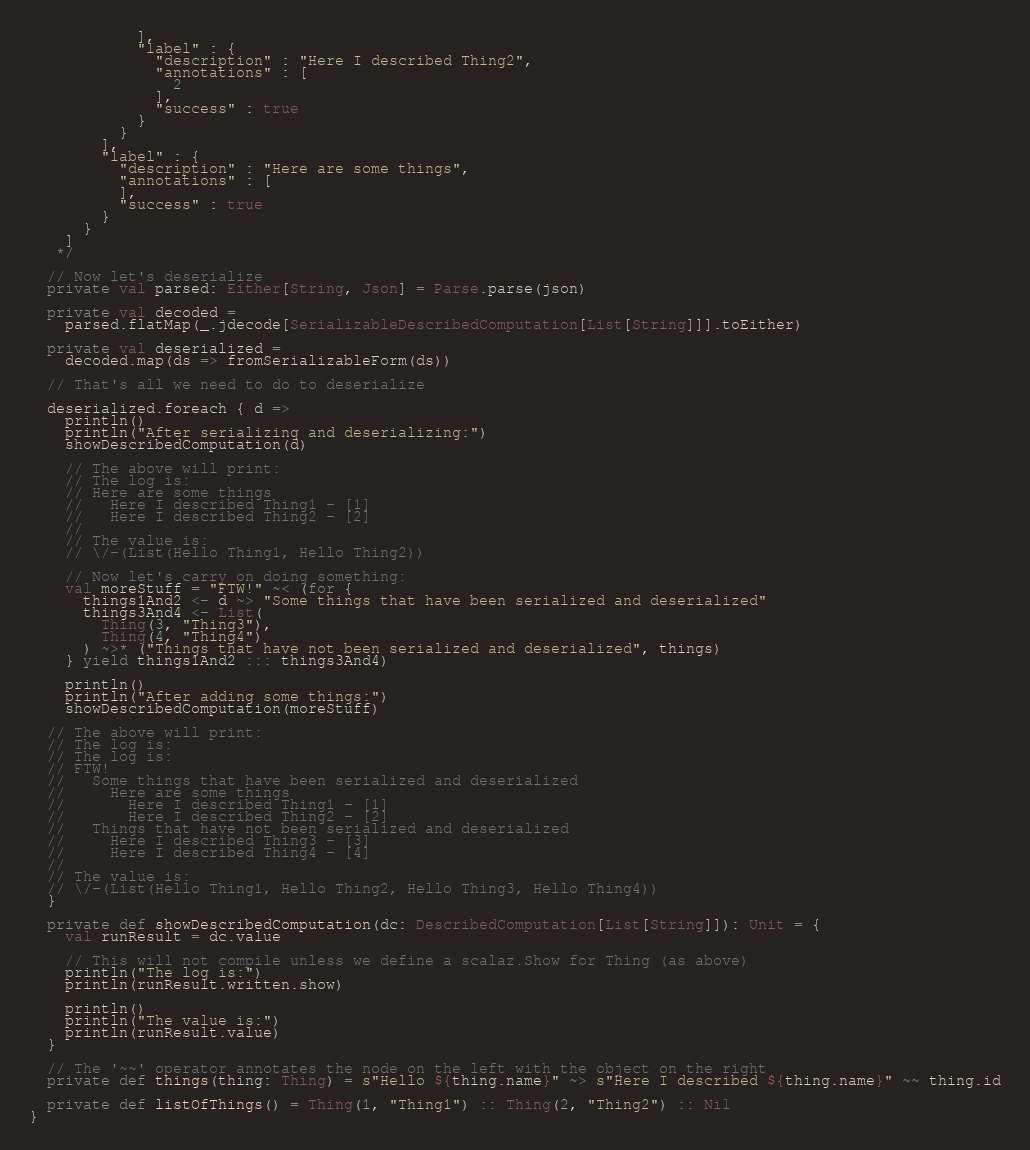Convert code to text. <code><loc_0><loc_0><loc_500><loc_500><_Scala_>            ],
            "label" : {
              "description" : "Here I described Thing2",
              "annotations" : [
                2
              ],
              "success" : true
            }
          }
        ],
        "label" : {
          "description" : "Here are some things",
          "annotations" : [
          ],
          "success" : true
        }
      }
    ]
   */

  // Now let's deserialize
  private val parsed: Either[String, Json] = Parse.parse(json)

  private val decoded =
    parsed.flatMap(_.jdecode[SerializableDescribedComputation[List[String]]].toEither)

  private val deserialized =
    decoded.map(ds => fromSerializableForm(ds))

  // That's all we need to do to deserialize

  deserialized.foreach { d =>
    println()
    println("After serializing and deserializing:")
    showDescribedComputation(d)

    // The above will print:
    // The log is:
    // Here are some things
    //   Here I described Thing1 - [1]
    //   Here I described Thing2 - [2]
    //
    // The value is:
    // \/-(List(Hello Thing1, Hello Thing2))

    // Now let's carry on doing something:
    val moreStuff = "FTW!" ~< (for {
      things1And2 <- d ~> "Some things that have been serialized and deserialized"
      things3And4 <- List(
        Thing(3, "Thing3"),
        Thing(4, "Thing4")
      ) ~>* ("Things that have not been serialized and deserialized", things)
    } yield things1And2 ::: things3And4)

    println()
    println("After adding some things:")
    showDescribedComputation(moreStuff)

  // The above will print:
  // The log is:
  // The log is:
  // FTW!
  //   Some things that have been serialized and deserialized
  //     Here are some things
  //       Here I described Thing1 - [1]
  //       Here I described Thing2 - [2]
  //   Things that have not been serialized and deserialized
  //     Here I described Thing3 - [3]
  //     Here I described Thing4 - [4]
  //
  // The value is:
  // \/-(List(Hello Thing1, Hello Thing2, Hello Thing3, Hello Thing4))
  }

  private def showDescribedComputation(dc: DescribedComputation[List[String]]): Unit = {
    val runResult = dc.value

    // This will not compile unless we define a scalaz.Show for Thing (as above)
    println("The log is:")
    println(runResult.written.show)

    println()
    println("The value is:")
    println(runResult.value)
  }

  // The '~~' operator annotates the node on the left with the object on the right
  private def things(thing: Thing) = s"Hello ${thing.name}" ~> s"Here I described ${thing.name}" ~~ thing.id

  private def listOfThings() = Thing(1, "Thing1") :: Thing(2, "Thing2") :: Nil
}
</code> 